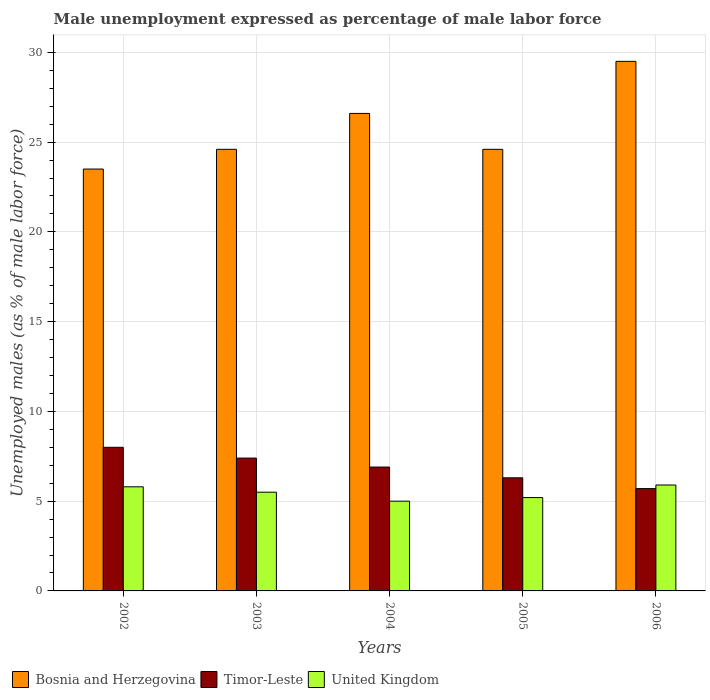How many different coloured bars are there?
Keep it short and to the point. 3. How many groups of bars are there?
Your answer should be very brief. 5. How many bars are there on the 4th tick from the right?
Your answer should be very brief. 3. In how many cases, is the number of bars for a given year not equal to the number of legend labels?
Offer a terse response. 0. What is the unemployment in males in in United Kingdom in 2005?
Your answer should be compact. 5.2. Across all years, what is the maximum unemployment in males in in United Kingdom?
Provide a short and direct response. 5.9. In which year was the unemployment in males in in United Kingdom maximum?
Make the answer very short. 2006. In which year was the unemployment in males in in Bosnia and Herzegovina minimum?
Provide a short and direct response. 2002. What is the total unemployment in males in in Bosnia and Herzegovina in the graph?
Offer a terse response. 128.8. What is the difference between the unemployment in males in in United Kingdom in 2005 and that in 2006?
Keep it short and to the point. -0.7. What is the difference between the unemployment in males in in United Kingdom in 2006 and the unemployment in males in in Timor-Leste in 2004?
Your response must be concise. -1. What is the average unemployment in males in in Timor-Leste per year?
Keep it short and to the point. 6.86. In the year 2005, what is the difference between the unemployment in males in in United Kingdom and unemployment in males in in Timor-Leste?
Your answer should be compact. -1.1. In how many years, is the unemployment in males in in Timor-Leste greater than 10 %?
Make the answer very short. 0. What is the ratio of the unemployment in males in in Timor-Leste in 2003 to that in 2004?
Ensure brevity in your answer.  1.07. Is the unemployment in males in in United Kingdom in 2003 less than that in 2005?
Give a very brief answer. No. What is the difference between the highest and the second highest unemployment in males in in Timor-Leste?
Keep it short and to the point. 0.6. What is the difference between the highest and the lowest unemployment in males in in Timor-Leste?
Your answer should be compact. 2.3. Is the sum of the unemployment in males in in Bosnia and Herzegovina in 2002 and 2004 greater than the maximum unemployment in males in in Timor-Leste across all years?
Ensure brevity in your answer.  Yes. What does the 2nd bar from the left in 2005 represents?
Keep it short and to the point. Timor-Leste. How many years are there in the graph?
Your answer should be compact. 5. Are the values on the major ticks of Y-axis written in scientific E-notation?
Ensure brevity in your answer.  No. Where does the legend appear in the graph?
Provide a short and direct response. Bottom left. What is the title of the graph?
Offer a terse response. Male unemployment expressed as percentage of male labor force. Does "Myanmar" appear as one of the legend labels in the graph?
Provide a succinct answer. No. What is the label or title of the Y-axis?
Give a very brief answer. Unemployed males (as % of male labor force). What is the Unemployed males (as % of male labor force) of United Kingdom in 2002?
Make the answer very short. 5.8. What is the Unemployed males (as % of male labor force) of Bosnia and Herzegovina in 2003?
Keep it short and to the point. 24.6. What is the Unemployed males (as % of male labor force) in Timor-Leste in 2003?
Offer a terse response. 7.4. What is the Unemployed males (as % of male labor force) in Bosnia and Herzegovina in 2004?
Offer a terse response. 26.6. What is the Unemployed males (as % of male labor force) of Timor-Leste in 2004?
Offer a very short reply. 6.9. What is the Unemployed males (as % of male labor force) of United Kingdom in 2004?
Your answer should be very brief. 5. What is the Unemployed males (as % of male labor force) of Bosnia and Herzegovina in 2005?
Offer a terse response. 24.6. What is the Unemployed males (as % of male labor force) in Timor-Leste in 2005?
Provide a short and direct response. 6.3. What is the Unemployed males (as % of male labor force) in United Kingdom in 2005?
Keep it short and to the point. 5.2. What is the Unemployed males (as % of male labor force) of Bosnia and Herzegovina in 2006?
Your answer should be very brief. 29.5. What is the Unemployed males (as % of male labor force) in Timor-Leste in 2006?
Offer a very short reply. 5.7. What is the Unemployed males (as % of male labor force) in United Kingdom in 2006?
Offer a very short reply. 5.9. Across all years, what is the maximum Unemployed males (as % of male labor force) in Bosnia and Herzegovina?
Make the answer very short. 29.5. Across all years, what is the maximum Unemployed males (as % of male labor force) in Timor-Leste?
Your answer should be compact. 8. Across all years, what is the maximum Unemployed males (as % of male labor force) in United Kingdom?
Provide a short and direct response. 5.9. Across all years, what is the minimum Unemployed males (as % of male labor force) of Timor-Leste?
Offer a very short reply. 5.7. What is the total Unemployed males (as % of male labor force) in Bosnia and Herzegovina in the graph?
Provide a short and direct response. 128.8. What is the total Unemployed males (as % of male labor force) of Timor-Leste in the graph?
Keep it short and to the point. 34.3. What is the total Unemployed males (as % of male labor force) in United Kingdom in the graph?
Make the answer very short. 27.4. What is the difference between the Unemployed males (as % of male labor force) of Bosnia and Herzegovina in 2002 and that in 2003?
Ensure brevity in your answer.  -1.1. What is the difference between the Unemployed males (as % of male labor force) of Timor-Leste in 2002 and that in 2003?
Your answer should be compact. 0.6. What is the difference between the Unemployed males (as % of male labor force) of United Kingdom in 2002 and that in 2003?
Your answer should be compact. 0.3. What is the difference between the Unemployed males (as % of male labor force) in Bosnia and Herzegovina in 2002 and that in 2004?
Provide a succinct answer. -3.1. What is the difference between the Unemployed males (as % of male labor force) of Bosnia and Herzegovina in 2003 and that in 2004?
Keep it short and to the point. -2. What is the difference between the Unemployed males (as % of male labor force) in United Kingdom in 2003 and that in 2004?
Provide a short and direct response. 0.5. What is the difference between the Unemployed males (as % of male labor force) in Bosnia and Herzegovina in 2003 and that in 2005?
Make the answer very short. 0. What is the difference between the Unemployed males (as % of male labor force) in Bosnia and Herzegovina in 2003 and that in 2006?
Make the answer very short. -4.9. What is the difference between the Unemployed males (as % of male labor force) of United Kingdom in 2003 and that in 2006?
Offer a terse response. -0.4. What is the difference between the Unemployed males (as % of male labor force) in Timor-Leste in 2004 and that in 2005?
Make the answer very short. 0.6. What is the difference between the Unemployed males (as % of male labor force) in Bosnia and Herzegovina in 2004 and that in 2006?
Your answer should be very brief. -2.9. What is the difference between the Unemployed males (as % of male labor force) in Timor-Leste in 2004 and that in 2006?
Make the answer very short. 1.2. What is the difference between the Unemployed males (as % of male labor force) of United Kingdom in 2005 and that in 2006?
Give a very brief answer. -0.7. What is the difference between the Unemployed males (as % of male labor force) of Bosnia and Herzegovina in 2002 and the Unemployed males (as % of male labor force) of Timor-Leste in 2003?
Ensure brevity in your answer.  16.1. What is the difference between the Unemployed males (as % of male labor force) of Bosnia and Herzegovina in 2002 and the Unemployed males (as % of male labor force) of United Kingdom in 2004?
Make the answer very short. 18.5. What is the difference between the Unemployed males (as % of male labor force) of Timor-Leste in 2002 and the Unemployed males (as % of male labor force) of United Kingdom in 2004?
Your answer should be compact. 3. What is the difference between the Unemployed males (as % of male labor force) of Bosnia and Herzegovina in 2002 and the Unemployed males (as % of male labor force) of Timor-Leste in 2005?
Your response must be concise. 17.2. What is the difference between the Unemployed males (as % of male labor force) in Timor-Leste in 2002 and the Unemployed males (as % of male labor force) in United Kingdom in 2005?
Keep it short and to the point. 2.8. What is the difference between the Unemployed males (as % of male labor force) in Bosnia and Herzegovina in 2002 and the Unemployed males (as % of male labor force) in United Kingdom in 2006?
Give a very brief answer. 17.6. What is the difference between the Unemployed males (as % of male labor force) of Timor-Leste in 2002 and the Unemployed males (as % of male labor force) of United Kingdom in 2006?
Your answer should be very brief. 2.1. What is the difference between the Unemployed males (as % of male labor force) in Bosnia and Herzegovina in 2003 and the Unemployed males (as % of male labor force) in United Kingdom in 2004?
Provide a short and direct response. 19.6. What is the difference between the Unemployed males (as % of male labor force) of Timor-Leste in 2003 and the Unemployed males (as % of male labor force) of United Kingdom in 2004?
Your answer should be compact. 2.4. What is the difference between the Unemployed males (as % of male labor force) in Timor-Leste in 2003 and the Unemployed males (as % of male labor force) in United Kingdom in 2005?
Provide a succinct answer. 2.2. What is the difference between the Unemployed males (as % of male labor force) of Bosnia and Herzegovina in 2003 and the Unemployed males (as % of male labor force) of Timor-Leste in 2006?
Keep it short and to the point. 18.9. What is the difference between the Unemployed males (as % of male labor force) of Timor-Leste in 2003 and the Unemployed males (as % of male labor force) of United Kingdom in 2006?
Offer a very short reply. 1.5. What is the difference between the Unemployed males (as % of male labor force) of Bosnia and Herzegovina in 2004 and the Unemployed males (as % of male labor force) of Timor-Leste in 2005?
Provide a succinct answer. 20.3. What is the difference between the Unemployed males (as % of male labor force) in Bosnia and Herzegovina in 2004 and the Unemployed males (as % of male labor force) in United Kingdom in 2005?
Your answer should be very brief. 21.4. What is the difference between the Unemployed males (as % of male labor force) of Timor-Leste in 2004 and the Unemployed males (as % of male labor force) of United Kingdom in 2005?
Provide a succinct answer. 1.7. What is the difference between the Unemployed males (as % of male labor force) of Bosnia and Herzegovina in 2004 and the Unemployed males (as % of male labor force) of Timor-Leste in 2006?
Offer a very short reply. 20.9. What is the difference between the Unemployed males (as % of male labor force) in Bosnia and Herzegovina in 2004 and the Unemployed males (as % of male labor force) in United Kingdom in 2006?
Make the answer very short. 20.7. What is the difference between the Unemployed males (as % of male labor force) in Bosnia and Herzegovina in 2005 and the Unemployed males (as % of male labor force) in United Kingdom in 2006?
Keep it short and to the point. 18.7. What is the average Unemployed males (as % of male labor force) of Bosnia and Herzegovina per year?
Give a very brief answer. 25.76. What is the average Unemployed males (as % of male labor force) of Timor-Leste per year?
Offer a very short reply. 6.86. What is the average Unemployed males (as % of male labor force) in United Kingdom per year?
Your response must be concise. 5.48. In the year 2002, what is the difference between the Unemployed males (as % of male labor force) of Timor-Leste and Unemployed males (as % of male labor force) of United Kingdom?
Provide a succinct answer. 2.2. In the year 2003, what is the difference between the Unemployed males (as % of male labor force) in Bosnia and Herzegovina and Unemployed males (as % of male labor force) in Timor-Leste?
Your answer should be compact. 17.2. In the year 2003, what is the difference between the Unemployed males (as % of male labor force) in Bosnia and Herzegovina and Unemployed males (as % of male labor force) in United Kingdom?
Provide a succinct answer. 19.1. In the year 2003, what is the difference between the Unemployed males (as % of male labor force) of Timor-Leste and Unemployed males (as % of male labor force) of United Kingdom?
Provide a short and direct response. 1.9. In the year 2004, what is the difference between the Unemployed males (as % of male labor force) in Bosnia and Herzegovina and Unemployed males (as % of male labor force) in United Kingdom?
Your answer should be very brief. 21.6. In the year 2004, what is the difference between the Unemployed males (as % of male labor force) in Timor-Leste and Unemployed males (as % of male labor force) in United Kingdom?
Make the answer very short. 1.9. In the year 2005, what is the difference between the Unemployed males (as % of male labor force) in Bosnia and Herzegovina and Unemployed males (as % of male labor force) in Timor-Leste?
Provide a succinct answer. 18.3. In the year 2005, what is the difference between the Unemployed males (as % of male labor force) of Bosnia and Herzegovina and Unemployed males (as % of male labor force) of United Kingdom?
Keep it short and to the point. 19.4. In the year 2006, what is the difference between the Unemployed males (as % of male labor force) of Bosnia and Herzegovina and Unemployed males (as % of male labor force) of Timor-Leste?
Your answer should be compact. 23.8. In the year 2006, what is the difference between the Unemployed males (as % of male labor force) of Bosnia and Herzegovina and Unemployed males (as % of male labor force) of United Kingdom?
Provide a short and direct response. 23.6. What is the ratio of the Unemployed males (as % of male labor force) of Bosnia and Herzegovina in 2002 to that in 2003?
Offer a very short reply. 0.96. What is the ratio of the Unemployed males (as % of male labor force) of Timor-Leste in 2002 to that in 2003?
Keep it short and to the point. 1.08. What is the ratio of the Unemployed males (as % of male labor force) in United Kingdom in 2002 to that in 2003?
Keep it short and to the point. 1.05. What is the ratio of the Unemployed males (as % of male labor force) in Bosnia and Herzegovina in 2002 to that in 2004?
Give a very brief answer. 0.88. What is the ratio of the Unemployed males (as % of male labor force) of Timor-Leste in 2002 to that in 2004?
Your answer should be very brief. 1.16. What is the ratio of the Unemployed males (as % of male labor force) in United Kingdom in 2002 to that in 2004?
Your answer should be very brief. 1.16. What is the ratio of the Unemployed males (as % of male labor force) of Bosnia and Herzegovina in 2002 to that in 2005?
Your answer should be compact. 0.96. What is the ratio of the Unemployed males (as % of male labor force) in Timor-Leste in 2002 to that in 2005?
Keep it short and to the point. 1.27. What is the ratio of the Unemployed males (as % of male labor force) of United Kingdom in 2002 to that in 2005?
Your answer should be compact. 1.12. What is the ratio of the Unemployed males (as % of male labor force) of Bosnia and Herzegovina in 2002 to that in 2006?
Keep it short and to the point. 0.8. What is the ratio of the Unemployed males (as % of male labor force) of Timor-Leste in 2002 to that in 2006?
Your answer should be compact. 1.4. What is the ratio of the Unemployed males (as % of male labor force) in United Kingdom in 2002 to that in 2006?
Provide a succinct answer. 0.98. What is the ratio of the Unemployed males (as % of male labor force) of Bosnia and Herzegovina in 2003 to that in 2004?
Give a very brief answer. 0.92. What is the ratio of the Unemployed males (as % of male labor force) of Timor-Leste in 2003 to that in 2004?
Offer a terse response. 1.07. What is the ratio of the Unemployed males (as % of male labor force) in Bosnia and Herzegovina in 2003 to that in 2005?
Give a very brief answer. 1. What is the ratio of the Unemployed males (as % of male labor force) in Timor-Leste in 2003 to that in 2005?
Ensure brevity in your answer.  1.17. What is the ratio of the Unemployed males (as % of male labor force) in United Kingdom in 2003 to that in 2005?
Your answer should be very brief. 1.06. What is the ratio of the Unemployed males (as % of male labor force) of Bosnia and Herzegovina in 2003 to that in 2006?
Give a very brief answer. 0.83. What is the ratio of the Unemployed males (as % of male labor force) of Timor-Leste in 2003 to that in 2006?
Offer a very short reply. 1.3. What is the ratio of the Unemployed males (as % of male labor force) of United Kingdom in 2003 to that in 2006?
Your response must be concise. 0.93. What is the ratio of the Unemployed males (as % of male labor force) in Bosnia and Herzegovina in 2004 to that in 2005?
Keep it short and to the point. 1.08. What is the ratio of the Unemployed males (as % of male labor force) of Timor-Leste in 2004 to that in 2005?
Provide a short and direct response. 1.1. What is the ratio of the Unemployed males (as % of male labor force) in United Kingdom in 2004 to that in 2005?
Make the answer very short. 0.96. What is the ratio of the Unemployed males (as % of male labor force) in Bosnia and Herzegovina in 2004 to that in 2006?
Your response must be concise. 0.9. What is the ratio of the Unemployed males (as % of male labor force) of Timor-Leste in 2004 to that in 2006?
Your answer should be compact. 1.21. What is the ratio of the Unemployed males (as % of male labor force) of United Kingdom in 2004 to that in 2006?
Give a very brief answer. 0.85. What is the ratio of the Unemployed males (as % of male labor force) in Bosnia and Herzegovina in 2005 to that in 2006?
Your answer should be very brief. 0.83. What is the ratio of the Unemployed males (as % of male labor force) of Timor-Leste in 2005 to that in 2006?
Provide a short and direct response. 1.11. What is the ratio of the Unemployed males (as % of male labor force) in United Kingdom in 2005 to that in 2006?
Ensure brevity in your answer.  0.88. What is the difference between the highest and the second highest Unemployed males (as % of male labor force) of Bosnia and Herzegovina?
Offer a terse response. 2.9. What is the difference between the highest and the lowest Unemployed males (as % of male labor force) of Bosnia and Herzegovina?
Your answer should be very brief. 6. What is the difference between the highest and the lowest Unemployed males (as % of male labor force) in United Kingdom?
Provide a short and direct response. 0.9. 